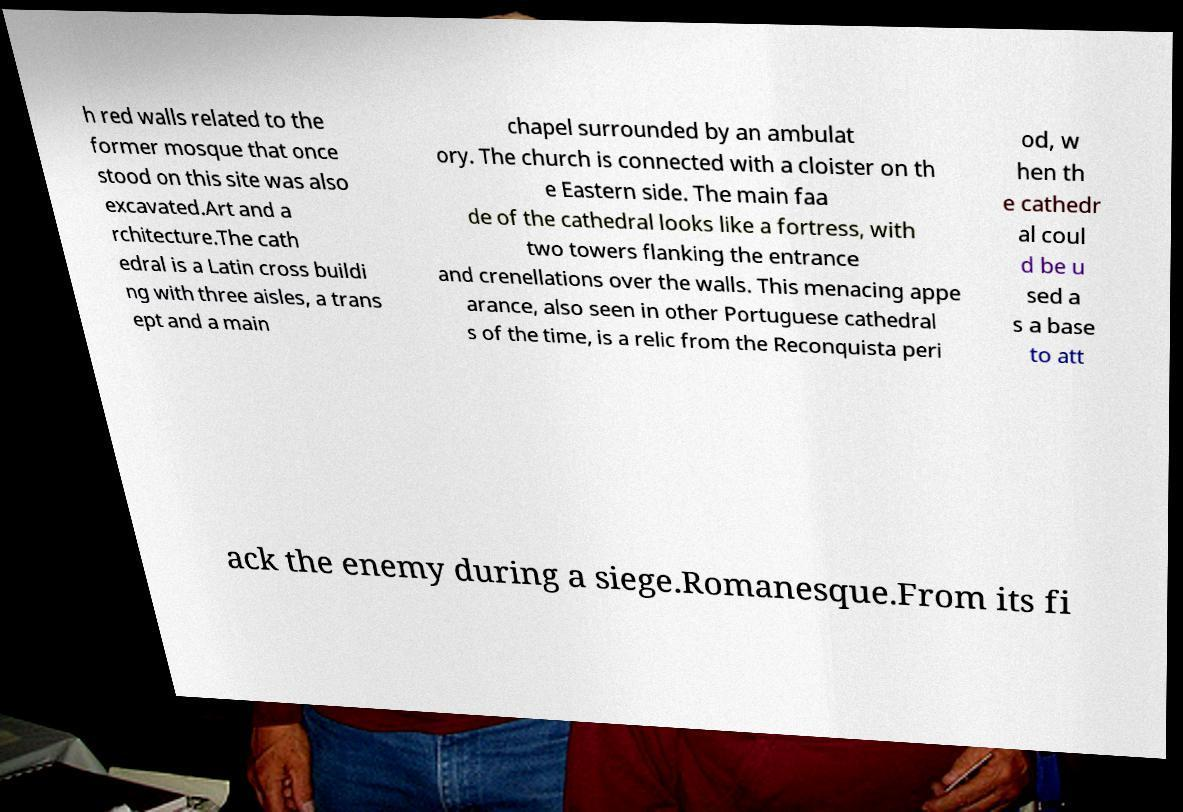Can you read and provide the text displayed in the image?This photo seems to have some interesting text. Can you extract and type it out for me? h red walls related to the former mosque that once stood on this site was also excavated.Art and a rchitecture.The cath edral is a Latin cross buildi ng with three aisles, a trans ept and a main chapel surrounded by an ambulat ory. The church is connected with a cloister on th e Eastern side. The main faa de of the cathedral looks like a fortress, with two towers flanking the entrance and crenellations over the walls. This menacing appe arance, also seen in other Portuguese cathedral s of the time, is a relic from the Reconquista peri od, w hen th e cathedr al coul d be u sed a s a base to att ack the enemy during a siege.Romanesque.From its fi 